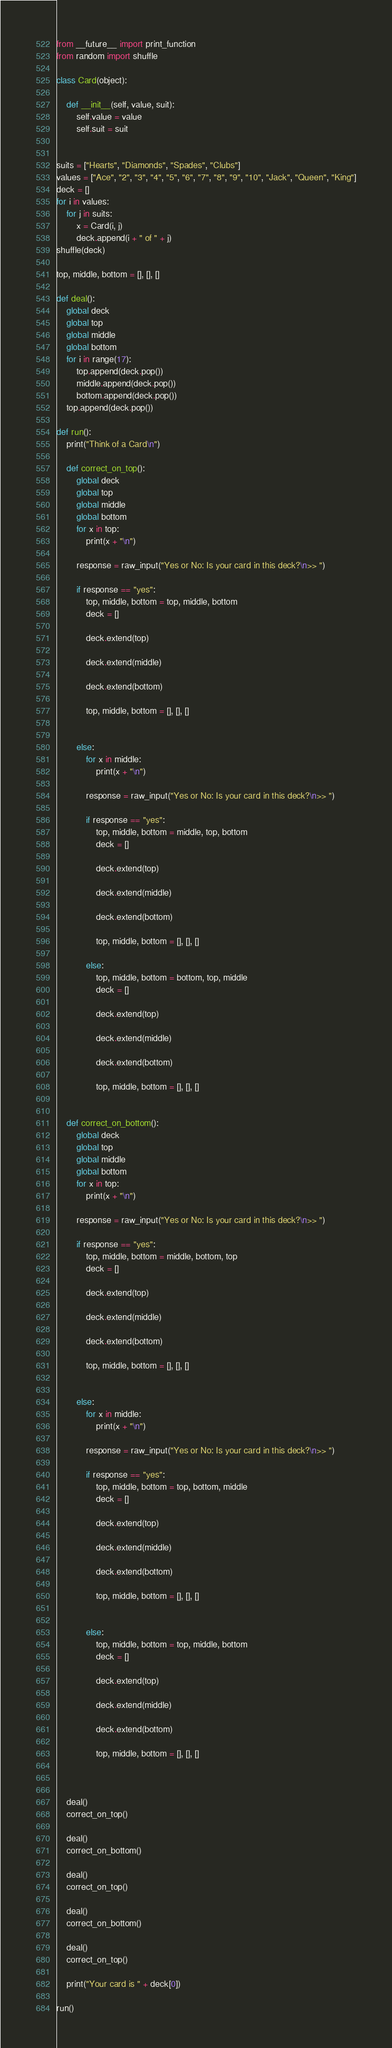Convert code to text. <code><loc_0><loc_0><loc_500><loc_500><_Python_>from __future__ import print_function
from random import shuffle

class Card(object):
    
    def __init__(self, value, suit):
        self.value = value
        self.suit = suit


suits = ["Hearts", "Diamonds", "Spades", "Clubs"]
values = ["Ace", "2", "3", "4", "5", "6", "7", "8", "9", "10", "Jack", "Queen", "King"]
deck = []
for i in values:
    for j in suits:
        x = Card(i, j)
        deck.append(i + " of " + j)       
shuffle(deck)

top, middle, bottom = [], [], []

def deal():
    global deck
    global top
    global middle
    global bottom
    for i in range(17):
        top.append(deck.pop())
        middle.append(deck.pop())
        bottom.append(deck.pop())
    top.append(deck.pop())
   
def run():
    print("Think of a Card\n")
    
    def correct_on_top():
        global deck
        global top
        global middle
        global bottom
        for x in top:
            print(x + "\n")
            
        response = raw_input("Yes or No: Is your card in this deck?\n>> ")
        
        if response == "yes":
            top, middle, bottom = top, middle, bottom
            deck = []
        
            deck.extend(top)
        
            deck.extend(middle)
            
            deck.extend(bottom)
            
            top, middle, bottom = [], [], []
            
        
        else:
            for x in middle:
                print(x + "\n")
            
            response = raw_input("Yes or No: Is your card in this deck?\n>> ")
            
            if response == "yes":
                top, middle, bottom = middle, top, bottom
                deck = []
                
                deck.extend(top)
                
                deck.extend(middle)
                
                deck.extend(bottom)
                
                top, middle, bottom = [], [], []
                
            else:
                top, middle, bottom = bottom, top, middle
                deck = []
                
                deck.extend(top)
                
                deck.extend(middle)
                
                deck.extend(bottom)
                
                top, middle, bottom = [], [], []
            
            
    def correct_on_bottom():
        global deck
        global top
        global middle
        global bottom
        for x in top:
            print(x + "\n")
            
        response = raw_input("Yes or No: Is your card in this deck?\n>> ")
        
        if response == "yes":
            top, middle, bottom = middle, bottom, top
            deck = []
            
            deck.extend(top)
                
            deck.extend(middle)
                
            deck.extend(bottom)
                
            top, middle, bottom = [], [], []
            
            
        else:
            for x in middle:
                print(x + "\n")
            
            response = raw_input("Yes or No: Is your card in this deck?\n>> ")
            
            if response == "yes":
                top, middle, bottom = top, bottom, middle
                deck = []
                
                deck.extend(top)
                
                deck.extend(middle)
                
                deck.extend(bottom)
                    
                top, middle, bottom = [], [], []
                
                
            else:
                top, middle, bottom = top, middle, bottom
                deck = []
                
                deck.extend(top)
                
                deck.extend(middle)
                
                deck.extend(bottom)
                    
                top, middle, bottom = [], [], []
                
                
    
    deal()
    correct_on_top()
    
    deal()
    correct_on_bottom()
    
    deal()
    correct_on_top()
    
    deal()
    correct_on_bottom()
    
    deal()
    correct_on_top()
    
    print("Your card is " + deck[0])
    
run()</code> 